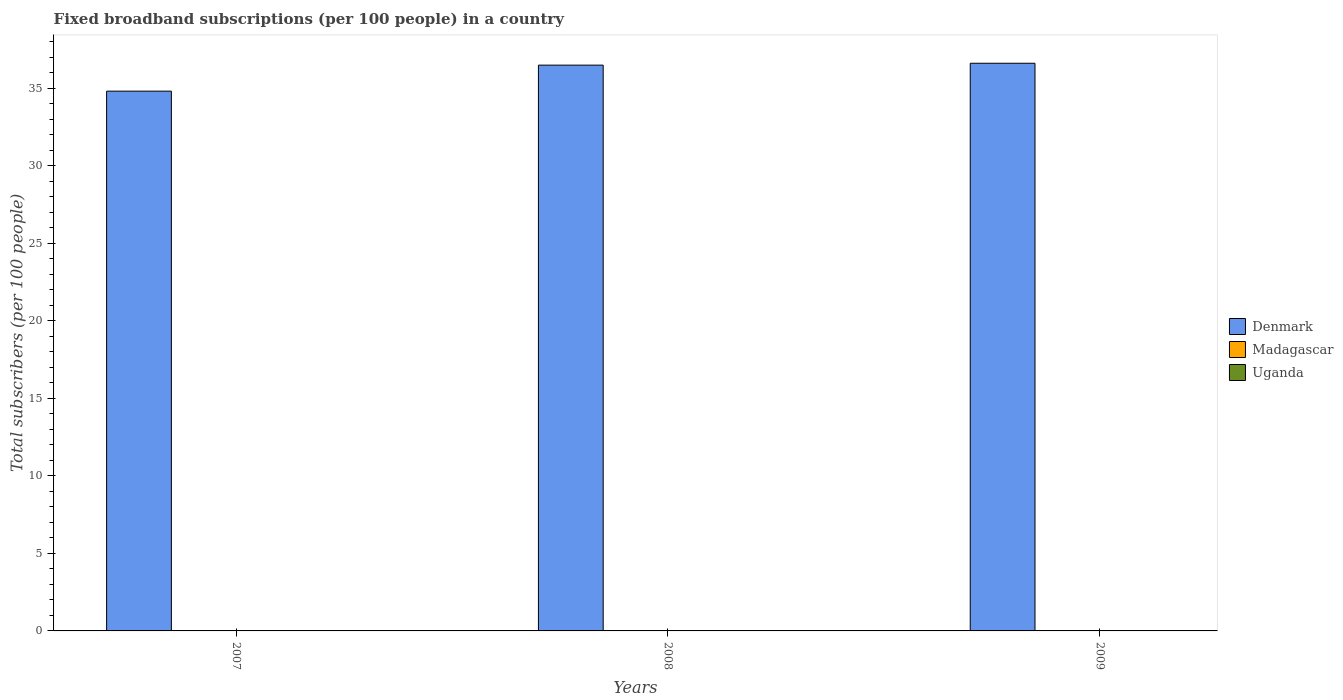How many different coloured bars are there?
Offer a terse response. 3. How many groups of bars are there?
Provide a succinct answer. 3. Are the number of bars per tick equal to the number of legend labels?
Give a very brief answer. Yes. How many bars are there on the 2nd tick from the left?
Give a very brief answer. 3. How many bars are there on the 1st tick from the right?
Your answer should be very brief. 3. What is the number of broadband subscriptions in Uganda in 2007?
Your response must be concise. 0.01. Across all years, what is the maximum number of broadband subscriptions in Uganda?
Make the answer very short. 0.02. Across all years, what is the minimum number of broadband subscriptions in Madagascar?
Keep it short and to the point. 0.01. What is the total number of broadband subscriptions in Denmark in the graph?
Your answer should be compact. 107.92. What is the difference between the number of broadband subscriptions in Denmark in 2007 and that in 2008?
Offer a terse response. -1.68. What is the difference between the number of broadband subscriptions in Uganda in 2008 and the number of broadband subscriptions in Denmark in 2007?
Your answer should be compact. -34.8. What is the average number of broadband subscriptions in Madagascar per year?
Offer a very short reply. 0.02. In the year 2007, what is the difference between the number of broadband subscriptions in Denmark and number of broadband subscriptions in Madagascar?
Your answer should be very brief. 34.8. In how many years, is the number of broadband subscriptions in Madagascar greater than 26?
Your answer should be very brief. 0. What is the ratio of the number of broadband subscriptions in Madagascar in 2008 to that in 2009?
Provide a short and direct response. 0.78. Is the number of broadband subscriptions in Madagascar in 2007 less than that in 2009?
Your response must be concise. Yes. What is the difference between the highest and the second highest number of broadband subscriptions in Denmark?
Offer a terse response. 0.12. What is the difference between the highest and the lowest number of broadband subscriptions in Uganda?
Provide a short and direct response. 0.01. In how many years, is the number of broadband subscriptions in Denmark greater than the average number of broadband subscriptions in Denmark taken over all years?
Give a very brief answer. 2. Is the sum of the number of broadband subscriptions in Uganda in 2007 and 2009 greater than the maximum number of broadband subscriptions in Denmark across all years?
Your answer should be compact. No. Is it the case that in every year, the sum of the number of broadband subscriptions in Madagascar and number of broadband subscriptions in Denmark is greater than the number of broadband subscriptions in Uganda?
Make the answer very short. Yes. How many bars are there?
Make the answer very short. 9. Are all the bars in the graph horizontal?
Make the answer very short. No. What is the difference between two consecutive major ticks on the Y-axis?
Your response must be concise. 5. Are the values on the major ticks of Y-axis written in scientific E-notation?
Offer a terse response. No. Does the graph contain grids?
Your answer should be very brief. No. Where does the legend appear in the graph?
Offer a terse response. Center right. How many legend labels are there?
Your response must be concise. 3. What is the title of the graph?
Your answer should be very brief. Fixed broadband subscriptions (per 100 people) in a country. Does "Oman" appear as one of the legend labels in the graph?
Offer a terse response. No. What is the label or title of the X-axis?
Offer a terse response. Years. What is the label or title of the Y-axis?
Your answer should be compact. Total subscribers (per 100 people). What is the Total subscribers (per 100 people) of Denmark in 2007?
Offer a terse response. 34.82. What is the Total subscribers (per 100 people) in Madagascar in 2007?
Provide a short and direct response. 0.01. What is the Total subscribers (per 100 people) in Uganda in 2007?
Provide a succinct answer. 0.01. What is the Total subscribers (per 100 people) of Denmark in 2008?
Offer a very short reply. 36.49. What is the Total subscribers (per 100 people) in Madagascar in 2008?
Make the answer very short. 0.02. What is the Total subscribers (per 100 people) of Uganda in 2008?
Keep it short and to the point. 0.02. What is the Total subscribers (per 100 people) of Denmark in 2009?
Offer a terse response. 36.61. What is the Total subscribers (per 100 people) in Madagascar in 2009?
Ensure brevity in your answer.  0.02. What is the Total subscribers (per 100 people) in Uganda in 2009?
Your response must be concise. 0.02. Across all years, what is the maximum Total subscribers (per 100 people) in Denmark?
Give a very brief answer. 36.61. Across all years, what is the maximum Total subscribers (per 100 people) of Madagascar?
Provide a succinct answer. 0.02. Across all years, what is the maximum Total subscribers (per 100 people) in Uganda?
Keep it short and to the point. 0.02. Across all years, what is the minimum Total subscribers (per 100 people) of Denmark?
Your answer should be very brief. 34.82. Across all years, what is the minimum Total subscribers (per 100 people) in Madagascar?
Offer a very short reply. 0.01. Across all years, what is the minimum Total subscribers (per 100 people) of Uganda?
Provide a succinct answer. 0.01. What is the total Total subscribers (per 100 people) of Denmark in the graph?
Offer a very short reply. 107.92. What is the total Total subscribers (per 100 people) of Madagascar in the graph?
Your answer should be compact. 0.05. What is the total Total subscribers (per 100 people) of Uganda in the graph?
Your answer should be very brief. 0.04. What is the difference between the Total subscribers (per 100 people) of Denmark in 2007 and that in 2008?
Provide a succinct answer. -1.68. What is the difference between the Total subscribers (per 100 people) in Madagascar in 2007 and that in 2008?
Ensure brevity in your answer.  -0.01. What is the difference between the Total subscribers (per 100 people) in Uganda in 2007 and that in 2008?
Ensure brevity in your answer.  -0.01. What is the difference between the Total subscribers (per 100 people) in Denmark in 2007 and that in 2009?
Provide a short and direct response. -1.8. What is the difference between the Total subscribers (per 100 people) of Madagascar in 2007 and that in 2009?
Provide a short and direct response. -0.01. What is the difference between the Total subscribers (per 100 people) of Uganda in 2007 and that in 2009?
Ensure brevity in your answer.  -0.01. What is the difference between the Total subscribers (per 100 people) of Denmark in 2008 and that in 2009?
Make the answer very short. -0.12. What is the difference between the Total subscribers (per 100 people) of Madagascar in 2008 and that in 2009?
Ensure brevity in your answer.  -0. What is the difference between the Total subscribers (per 100 people) of Uganda in 2008 and that in 2009?
Make the answer very short. -0. What is the difference between the Total subscribers (per 100 people) of Denmark in 2007 and the Total subscribers (per 100 people) of Madagascar in 2008?
Your answer should be compact. 34.8. What is the difference between the Total subscribers (per 100 people) in Denmark in 2007 and the Total subscribers (per 100 people) in Uganda in 2008?
Offer a terse response. 34.8. What is the difference between the Total subscribers (per 100 people) in Madagascar in 2007 and the Total subscribers (per 100 people) in Uganda in 2008?
Offer a very short reply. -0. What is the difference between the Total subscribers (per 100 people) of Denmark in 2007 and the Total subscribers (per 100 people) of Madagascar in 2009?
Provide a succinct answer. 34.79. What is the difference between the Total subscribers (per 100 people) in Denmark in 2007 and the Total subscribers (per 100 people) in Uganda in 2009?
Make the answer very short. 34.8. What is the difference between the Total subscribers (per 100 people) in Madagascar in 2007 and the Total subscribers (per 100 people) in Uganda in 2009?
Offer a very short reply. -0.01. What is the difference between the Total subscribers (per 100 people) of Denmark in 2008 and the Total subscribers (per 100 people) of Madagascar in 2009?
Your answer should be compact. 36.47. What is the difference between the Total subscribers (per 100 people) of Denmark in 2008 and the Total subscribers (per 100 people) of Uganda in 2009?
Provide a succinct answer. 36.47. What is the difference between the Total subscribers (per 100 people) of Madagascar in 2008 and the Total subscribers (per 100 people) of Uganda in 2009?
Your answer should be compact. -0. What is the average Total subscribers (per 100 people) of Denmark per year?
Keep it short and to the point. 35.97. What is the average Total subscribers (per 100 people) in Madagascar per year?
Provide a short and direct response. 0.02. What is the average Total subscribers (per 100 people) in Uganda per year?
Offer a terse response. 0.01. In the year 2007, what is the difference between the Total subscribers (per 100 people) in Denmark and Total subscribers (per 100 people) in Madagascar?
Make the answer very short. 34.8. In the year 2007, what is the difference between the Total subscribers (per 100 people) in Denmark and Total subscribers (per 100 people) in Uganda?
Your answer should be very brief. 34.81. In the year 2007, what is the difference between the Total subscribers (per 100 people) in Madagascar and Total subscribers (per 100 people) in Uganda?
Ensure brevity in your answer.  0.01. In the year 2008, what is the difference between the Total subscribers (per 100 people) of Denmark and Total subscribers (per 100 people) of Madagascar?
Offer a very short reply. 36.48. In the year 2008, what is the difference between the Total subscribers (per 100 people) of Denmark and Total subscribers (per 100 people) of Uganda?
Offer a terse response. 36.48. In the year 2008, what is the difference between the Total subscribers (per 100 people) in Madagascar and Total subscribers (per 100 people) in Uganda?
Offer a very short reply. 0. In the year 2009, what is the difference between the Total subscribers (per 100 people) in Denmark and Total subscribers (per 100 people) in Madagascar?
Make the answer very short. 36.59. In the year 2009, what is the difference between the Total subscribers (per 100 people) in Denmark and Total subscribers (per 100 people) in Uganda?
Your answer should be compact. 36.6. In the year 2009, what is the difference between the Total subscribers (per 100 people) of Madagascar and Total subscribers (per 100 people) of Uganda?
Offer a very short reply. 0. What is the ratio of the Total subscribers (per 100 people) of Denmark in 2007 to that in 2008?
Provide a succinct answer. 0.95. What is the ratio of the Total subscribers (per 100 people) in Madagascar in 2007 to that in 2008?
Offer a very short reply. 0.69. What is the ratio of the Total subscribers (per 100 people) in Uganda in 2007 to that in 2008?
Your answer should be compact. 0.4. What is the ratio of the Total subscribers (per 100 people) of Denmark in 2007 to that in 2009?
Offer a very short reply. 0.95. What is the ratio of the Total subscribers (per 100 people) of Madagascar in 2007 to that in 2009?
Give a very brief answer. 0.54. What is the ratio of the Total subscribers (per 100 people) of Uganda in 2007 to that in 2009?
Your answer should be compact. 0.33. What is the ratio of the Total subscribers (per 100 people) of Denmark in 2008 to that in 2009?
Provide a short and direct response. 1. What is the ratio of the Total subscribers (per 100 people) of Madagascar in 2008 to that in 2009?
Ensure brevity in your answer.  0.78. What is the ratio of the Total subscribers (per 100 people) of Uganda in 2008 to that in 2009?
Give a very brief answer. 0.83. What is the difference between the highest and the second highest Total subscribers (per 100 people) of Denmark?
Your answer should be compact. 0.12. What is the difference between the highest and the second highest Total subscribers (per 100 people) of Madagascar?
Your response must be concise. 0. What is the difference between the highest and the second highest Total subscribers (per 100 people) of Uganda?
Your answer should be compact. 0. What is the difference between the highest and the lowest Total subscribers (per 100 people) of Denmark?
Make the answer very short. 1.8. What is the difference between the highest and the lowest Total subscribers (per 100 people) of Madagascar?
Offer a terse response. 0.01. What is the difference between the highest and the lowest Total subscribers (per 100 people) of Uganda?
Provide a succinct answer. 0.01. 